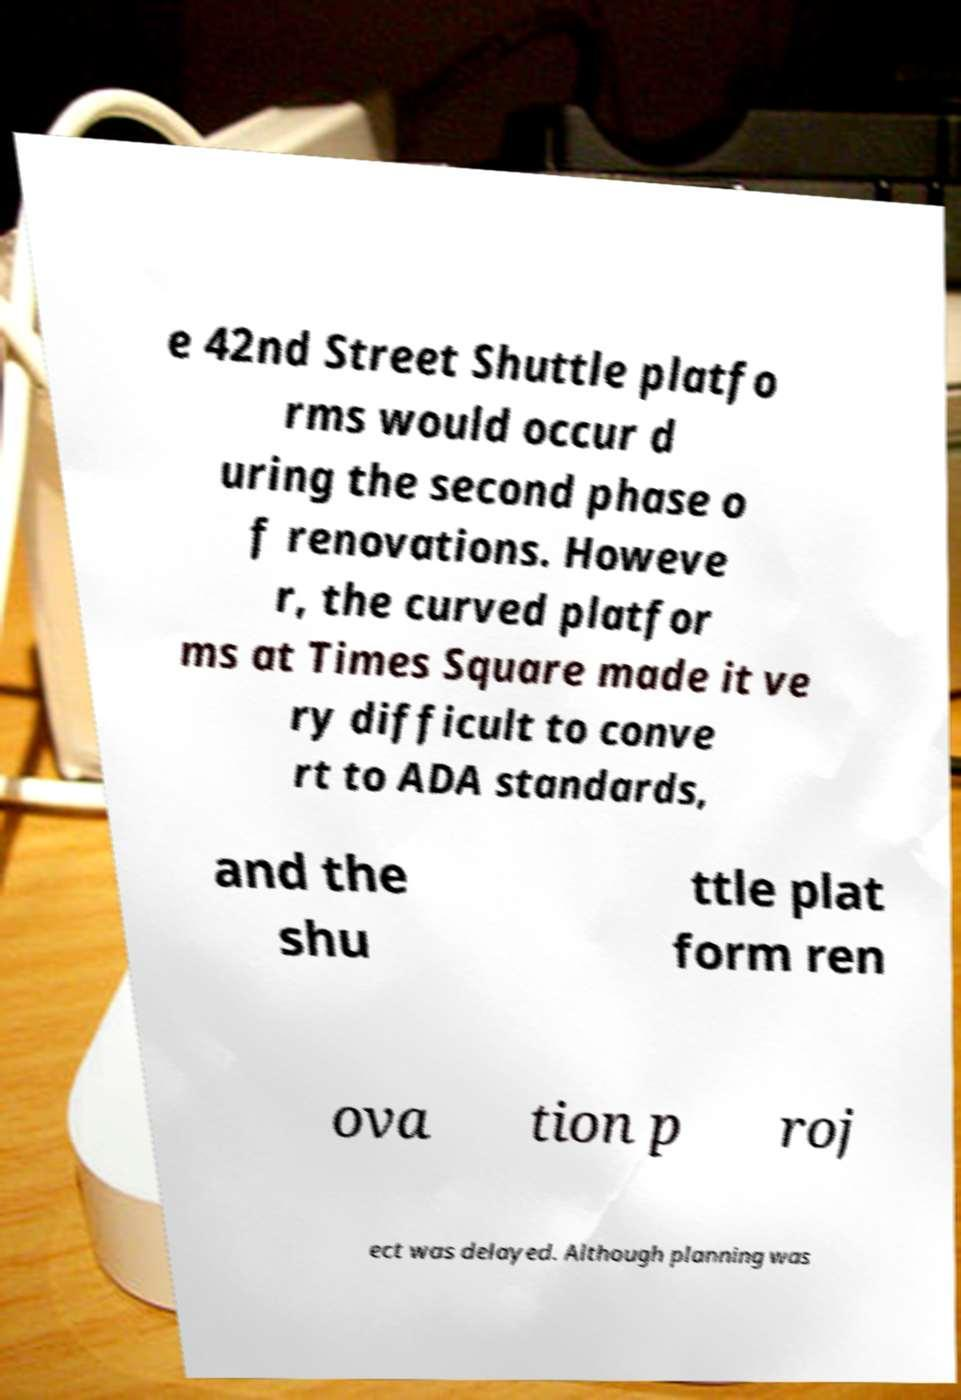Please identify and transcribe the text found in this image. e 42nd Street Shuttle platfo rms would occur d uring the second phase o f renovations. Howeve r, the curved platfor ms at Times Square made it ve ry difficult to conve rt to ADA standards, and the shu ttle plat form ren ova tion p roj ect was delayed. Although planning was 